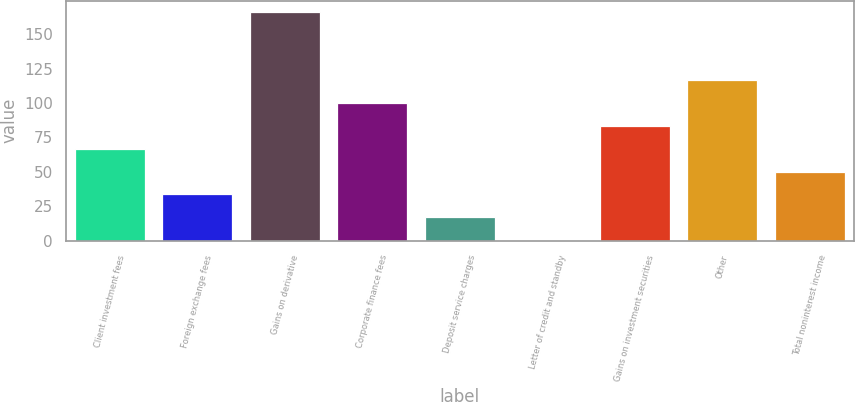<chart> <loc_0><loc_0><loc_500><loc_500><bar_chart><fcel>Client investment fees<fcel>Foreign exchange fees<fcel>Gains on derivative<fcel>Corporate finance fees<fcel>Deposit service charges<fcel>Letter of credit and standby<fcel>Gains on investment securities<fcel>Other<fcel>Total noninterest income<nl><fcel>66.72<fcel>33.66<fcel>165.9<fcel>99.78<fcel>17.13<fcel>0.6<fcel>83.25<fcel>116.31<fcel>50.19<nl></chart> 